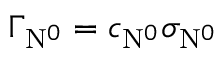<formula> <loc_0><loc_0><loc_500><loc_500>\Gamma _ { N ^ { 0 } } = c _ { N ^ { 0 } } \sigma _ { N ^ { 0 } }</formula> 